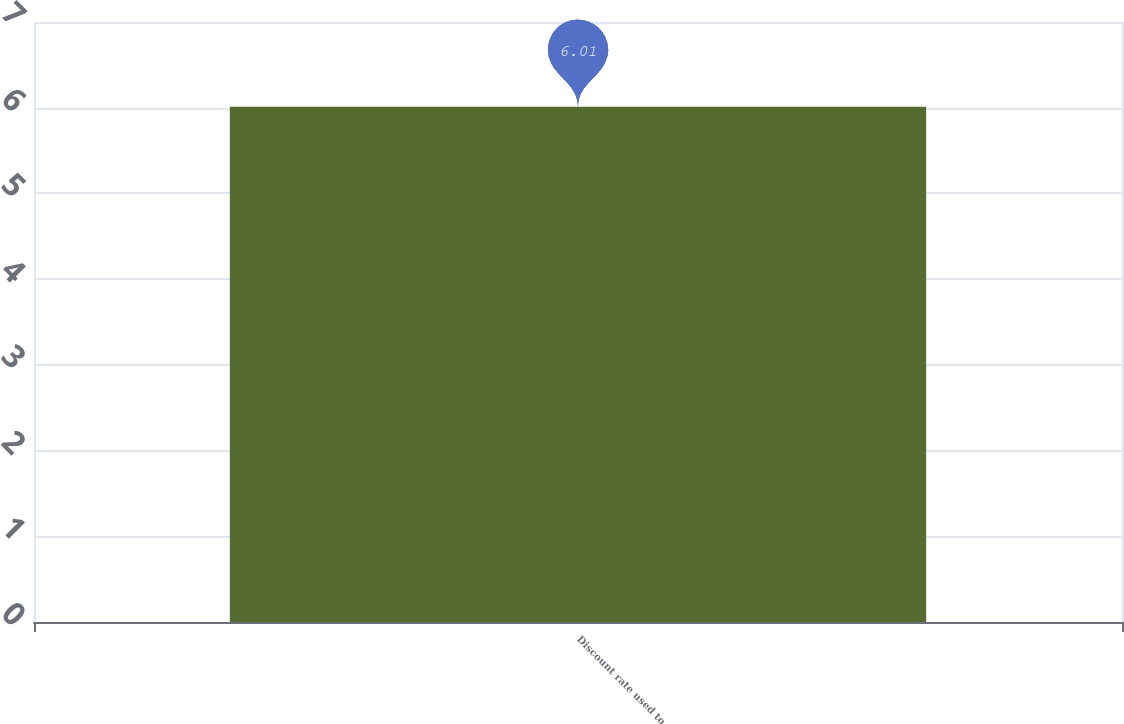Convert chart to OTSL. <chart><loc_0><loc_0><loc_500><loc_500><bar_chart><fcel>Discount rate used to<nl><fcel>6.01<nl></chart> 